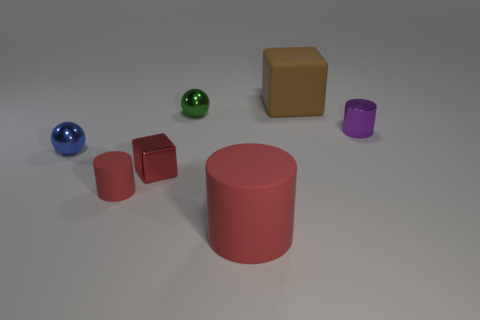How many spheres are visible, and can you describe their colors? In the image, there are two spheres. One is blue, and the other is green. 